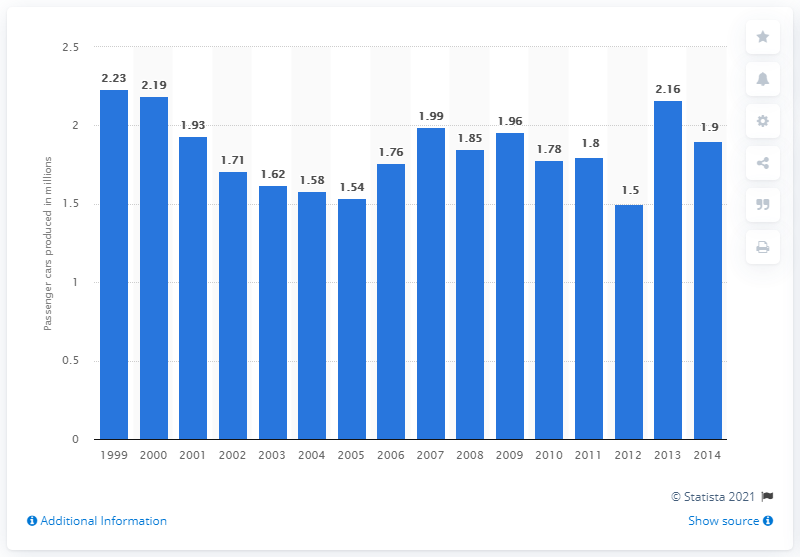Point out several critical features in this image. In 2013, Fiat produced 2,160,000 passenger vehicles. 